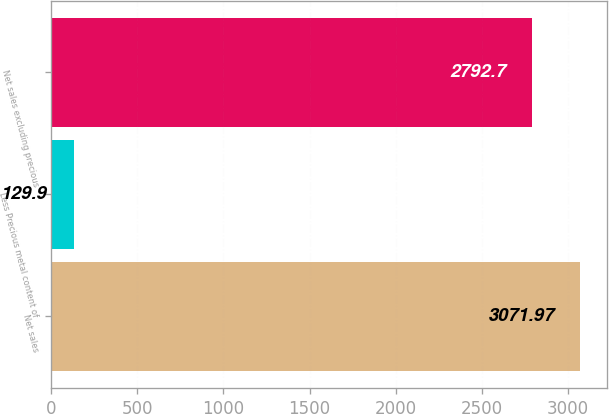Convert chart to OTSL. <chart><loc_0><loc_0><loc_500><loc_500><bar_chart><fcel>Net sales<fcel>Less Precious metal content of<fcel>Net sales excluding precious<nl><fcel>3071.97<fcel>129.9<fcel>2792.7<nl></chart> 